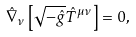<formula> <loc_0><loc_0><loc_500><loc_500>\hat { \nabla } _ { \nu } \left [ \sqrt { - \hat { g } } \hat { T } ^ { \mu \nu } \right ] = 0 ,</formula> 